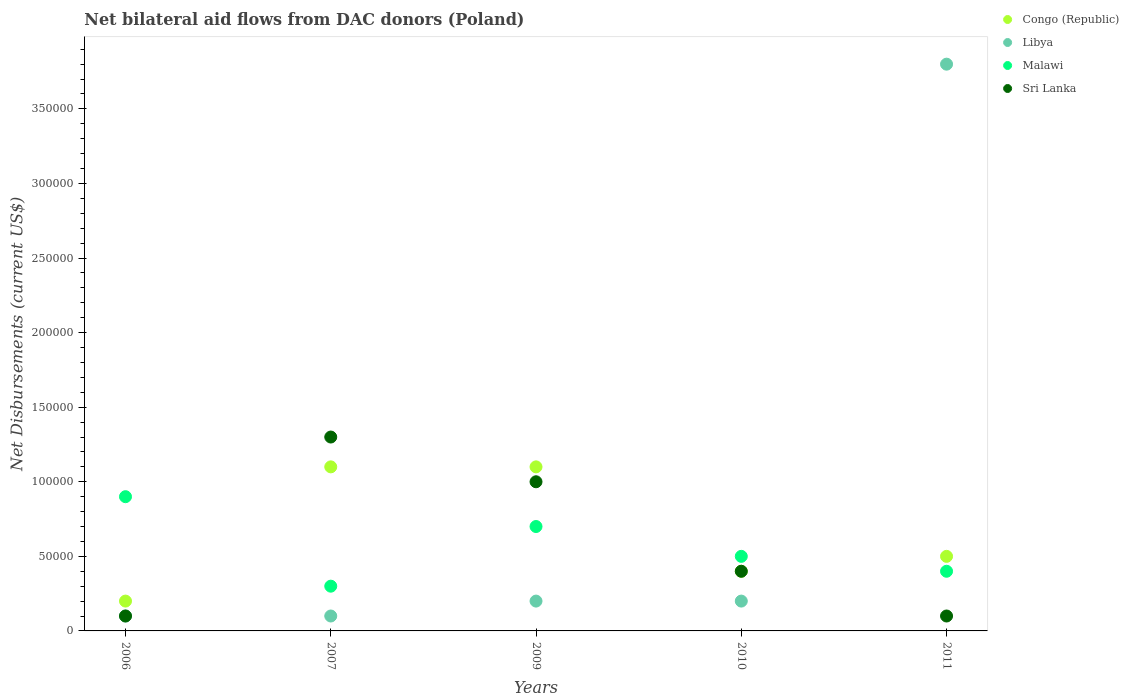How many different coloured dotlines are there?
Provide a short and direct response. 4. Across all years, what is the maximum net bilateral aid flows in Libya?
Give a very brief answer. 3.80e+05. Across all years, what is the minimum net bilateral aid flows in Congo (Republic)?
Keep it short and to the point. 2.00e+04. In which year was the net bilateral aid flows in Sri Lanka maximum?
Provide a short and direct response. 2007. In which year was the net bilateral aid flows in Sri Lanka minimum?
Keep it short and to the point. 2006. What is the difference between the net bilateral aid flows in Congo (Republic) in 2007 and that in 2009?
Offer a terse response. 0. What is the difference between the net bilateral aid flows in Sri Lanka in 2011 and the net bilateral aid flows in Libya in 2009?
Offer a terse response. -10000. What is the average net bilateral aid flows in Libya per year?
Ensure brevity in your answer.  8.80e+04. In the year 2009, what is the difference between the net bilateral aid flows in Libya and net bilateral aid flows in Malawi?
Make the answer very short. -5.00e+04. What is the ratio of the net bilateral aid flows in Sri Lanka in 2009 to that in 2011?
Your response must be concise. 10. What is the difference between the highest and the second highest net bilateral aid flows in Malawi?
Your answer should be very brief. 2.00e+04. What is the difference between the highest and the lowest net bilateral aid flows in Malawi?
Your answer should be very brief. 6.00e+04. In how many years, is the net bilateral aid flows in Libya greater than the average net bilateral aid flows in Libya taken over all years?
Your answer should be very brief. 1. Is the sum of the net bilateral aid flows in Libya in 2006 and 2010 greater than the maximum net bilateral aid flows in Sri Lanka across all years?
Your response must be concise. No. Is it the case that in every year, the sum of the net bilateral aid flows in Libya and net bilateral aid flows in Malawi  is greater than the net bilateral aid flows in Congo (Republic)?
Your response must be concise. No. Is the net bilateral aid flows in Sri Lanka strictly greater than the net bilateral aid flows in Congo (Republic) over the years?
Give a very brief answer. No. Is the net bilateral aid flows in Libya strictly less than the net bilateral aid flows in Congo (Republic) over the years?
Offer a very short reply. No. How many dotlines are there?
Your answer should be very brief. 4. Does the graph contain any zero values?
Keep it short and to the point. No. Does the graph contain grids?
Your response must be concise. No. How are the legend labels stacked?
Make the answer very short. Vertical. What is the title of the graph?
Your answer should be compact. Net bilateral aid flows from DAC donors (Poland). What is the label or title of the Y-axis?
Provide a succinct answer. Net Disbursements (current US$). What is the Net Disbursements (current US$) of Congo (Republic) in 2006?
Ensure brevity in your answer.  2.00e+04. What is the Net Disbursements (current US$) of Sri Lanka in 2006?
Offer a terse response. 10000. What is the Net Disbursements (current US$) of Sri Lanka in 2007?
Keep it short and to the point. 1.30e+05. What is the Net Disbursements (current US$) in Congo (Republic) in 2009?
Your response must be concise. 1.10e+05. What is the Net Disbursements (current US$) in Malawi in 2009?
Provide a short and direct response. 7.00e+04. What is the Net Disbursements (current US$) in Libya in 2010?
Your answer should be compact. 2.00e+04. What is the Net Disbursements (current US$) in Malawi in 2010?
Provide a short and direct response. 5.00e+04. What is the Net Disbursements (current US$) in Congo (Republic) in 2011?
Your response must be concise. 5.00e+04. What is the Net Disbursements (current US$) of Sri Lanka in 2011?
Provide a short and direct response. 10000. Across all years, what is the maximum Net Disbursements (current US$) of Congo (Republic)?
Ensure brevity in your answer.  1.10e+05. Across all years, what is the maximum Net Disbursements (current US$) in Libya?
Provide a succinct answer. 3.80e+05. Across all years, what is the maximum Net Disbursements (current US$) in Malawi?
Provide a succinct answer. 9.00e+04. Across all years, what is the maximum Net Disbursements (current US$) of Sri Lanka?
Keep it short and to the point. 1.30e+05. Across all years, what is the minimum Net Disbursements (current US$) in Congo (Republic)?
Keep it short and to the point. 2.00e+04. What is the total Net Disbursements (current US$) in Libya in the graph?
Give a very brief answer. 4.40e+05. What is the difference between the Net Disbursements (current US$) in Congo (Republic) in 2006 and that in 2007?
Your response must be concise. -9.00e+04. What is the difference between the Net Disbursements (current US$) in Sri Lanka in 2006 and that in 2007?
Your response must be concise. -1.20e+05. What is the difference between the Net Disbursements (current US$) in Congo (Republic) in 2006 and that in 2009?
Your answer should be very brief. -9.00e+04. What is the difference between the Net Disbursements (current US$) of Congo (Republic) in 2006 and that in 2010?
Your response must be concise. -2.00e+04. What is the difference between the Net Disbursements (current US$) in Libya in 2006 and that in 2011?
Make the answer very short. -3.70e+05. What is the difference between the Net Disbursements (current US$) in Sri Lanka in 2006 and that in 2011?
Offer a very short reply. 0. What is the difference between the Net Disbursements (current US$) in Libya in 2007 and that in 2009?
Provide a succinct answer. -10000. What is the difference between the Net Disbursements (current US$) in Congo (Republic) in 2007 and that in 2010?
Provide a succinct answer. 7.00e+04. What is the difference between the Net Disbursements (current US$) in Malawi in 2007 and that in 2010?
Ensure brevity in your answer.  -2.00e+04. What is the difference between the Net Disbursements (current US$) of Libya in 2007 and that in 2011?
Your answer should be very brief. -3.70e+05. What is the difference between the Net Disbursements (current US$) of Sri Lanka in 2007 and that in 2011?
Offer a terse response. 1.20e+05. What is the difference between the Net Disbursements (current US$) of Libya in 2009 and that in 2010?
Your answer should be very brief. 0. What is the difference between the Net Disbursements (current US$) of Sri Lanka in 2009 and that in 2010?
Ensure brevity in your answer.  6.00e+04. What is the difference between the Net Disbursements (current US$) of Congo (Republic) in 2009 and that in 2011?
Make the answer very short. 6.00e+04. What is the difference between the Net Disbursements (current US$) in Libya in 2009 and that in 2011?
Offer a very short reply. -3.60e+05. What is the difference between the Net Disbursements (current US$) in Malawi in 2009 and that in 2011?
Give a very brief answer. 3.00e+04. What is the difference between the Net Disbursements (current US$) of Congo (Republic) in 2010 and that in 2011?
Ensure brevity in your answer.  -10000. What is the difference between the Net Disbursements (current US$) of Libya in 2010 and that in 2011?
Make the answer very short. -3.60e+05. What is the difference between the Net Disbursements (current US$) in Malawi in 2010 and that in 2011?
Give a very brief answer. 10000. What is the difference between the Net Disbursements (current US$) in Sri Lanka in 2010 and that in 2011?
Make the answer very short. 3.00e+04. What is the difference between the Net Disbursements (current US$) in Congo (Republic) in 2006 and the Net Disbursements (current US$) in Malawi in 2007?
Provide a succinct answer. -10000. What is the difference between the Net Disbursements (current US$) of Libya in 2006 and the Net Disbursements (current US$) of Malawi in 2007?
Give a very brief answer. -2.00e+04. What is the difference between the Net Disbursements (current US$) of Libya in 2006 and the Net Disbursements (current US$) of Sri Lanka in 2007?
Your answer should be very brief. -1.20e+05. What is the difference between the Net Disbursements (current US$) of Malawi in 2006 and the Net Disbursements (current US$) of Sri Lanka in 2007?
Give a very brief answer. -4.00e+04. What is the difference between the Net Disbursements (current US$) of Congo (Republic) in 2006 and the Net Disbursements (current US$) of Malawi in 2009?
Provide a short and direct response. -5.00e+04. What is the difference between the Net Disbursements (current US$) in Libya in 2006 and the Net Disbursements (current US$) in Malawi in 2009?
Offer a terse response. -6.00e+04. What is the difference between the Net Disbursements (current US$) in Libya in 2006 and the Net Disbursements (current US$) in Sri Lanka in 2009?
Your answer should be compact. -9.00e+04. What is the difference between the Net Disbursements (current US$) of Congo (Republic) in 2006 and the Net Disbursements (current US$) of Libya in 2010?
Provide a short and direct response. 0. What is the difference between the Net Disbursements (current US$) in Congo (Republic) in 2006 and the Net Disbursements (current US$) in Malawi in 2010?
Provide a succinct answer. -3.00e+04. What is the difference between the Net Disbursements (current US$) in Congo (Republic) in 2006 and the Net Disbursements (current US$) in Sri Lanka in 2010?
Ensure brevity in your answer.  -2.00e+04. What is the difference between the Net Disbursements (current US$) of Libya in 2006 and the Net Disbursements (current US$) of Malawi in 2010?
Provide a short and direct response. -4.00e+04. What is the difference between the Net Disbursements (current US$) in Libya in 2006 and the Net Disbursements (current US$) in Sri Lanka in 2010?
Your answer should be very brief. -3.00e+04. What is the difference between the Net Disbursements (current US$) in Congo (Republic) in 2006 and the Net Disbursements (current US$) in Libya in 2011?
Your answer should be very brief. -3.60e+05. What is the difference between the Net Disbursements (current US$) in Congo (Republic) in 2006 and the Net Disbursements (current US$) in Malawi in 2011?
Give a very brief answer. -2.00e+04. What is the difference between the Net Disbursements (current US$) in Malawi in 2006 and the Net Disbursements (current US$) in Sri Lanka in 2011?
Ensure brevity in your answer.  8.00e+04. What is the difference between the Net Disbursements (current US$) of Congo (Republic) in 2007 and the Net Disbursements (current US$) of Libya in 2009?
Your response must be concise. 9.00e+04. What is the difference between the Net Disbursements (current US$) in Libya in 2007 and the Net Disbursements (current US$) in Malawi in 2009?
Give a very brief answer. -6.00e+04. What is the difference between the Net Disbursements (current US$) in Libya in 2007 and the Net Disbursements (current US$) in Sri Lanka in 2009?
Offer a very short reply. -9.00e+04. What is the difference between the Net Disbursements (current US$) in Congo (Republic) in 2007 and the Net Disbursements (current US$) in Libya in 2010?
Your answer should be compact. 9.00e+04. What is the difference between the Net Disbursements (current US$) of Congo (Republic) in 2007 and the Net Disbursements (current US$) of Malawi in 2010?
Keep it short and to the point. 6.00e+04. What is the difference between the Net Disbursements (current US$) of Libya in 2007 and the Net Disbursements (current US$) of Sri Lanka in 2010?
Your answer should be very brief. -3.00e+04. What is the difference between the Net Disbursements (current US$) in Congo (Republic) in 2007 and the Net Disbursements (current US$) in Malawi in 2011?
Ensure brevity in your answer.  7.00e+04. What is the difference between the Net Disbursements (current US$) of Libya in 2007 and the Net Disbursements (current US$) of Sri Lanka in 2011?
Offer a terse response. 0. What is the difference between the Net Disbursements (current US$) in Congo (Republic) in 2009 and the Net Disbursements (current US$) in Libya in 2010?
Make the answer very short. 9.00e+04. What is the difference between the Net Disbursements (current US$) in Congo (Republic) in 2009 and the Net Disbursements (current US$) in Malawi in 2010?
Provide a short and direct response. 6.00e+04. What is the difference between the Net Disbursements (current US$) in Malawi in 2009 and the Net Disbursements (current US$) in Sri Lanka in 2010?
Offer a very short reply. 3.00e+04. What is the difference between the Net Disbursements (current US$) of Congo (Republic) in 2009 and the Net Disbursements (current US$) of Libya in 2011?
Offer a very short reply. -2.70e+05. What is the difference between the Net Disbursements (current US$) of Congo (Republic) in 2009 and the Net Disbursements (current US$) of Sri Lanka in 2011?
Provide a succinct answer. 1.00e+05. What is the difference between the Net Disbursements (current US$) of Libya in 2009 and the Net Disbursements (current US$) of Malawi in 2011?
Keep it short and to the point. -2.00e+04. What is the difference between the Net Disbursements (current US$) of Libya in 2009 and the Net Disbursements (current US$) of Sri Lanka in 2011?
Give a very brief answer. 10000. What is the difference between the Net Disbursements (current US$) of Malawi in 2009 and the Net Disbursements (current US$) of Sri Lanka in 2011?
Give a very brief answer. 6.00e+04. What is the difference between the Net Disbursements (current US$) in Congo (Republic) in 2010 and the Net Disbursements (current US$) in Libya in 2011?
Provide a succinct answer. -3.40e+05. What is the difference between the Net Disbursements (current US$) of Congo (Republic) in 2010 and the Net Disbursements (current US$) of Malawi in 2011?
Offer a terse response. 0. What is the difference between the Net Disbursements (current US$) of Congo (Republic) in 2010 and the Net Disbursements (current US$) of Sri Lanka in 2011?
Keep it short and to the point. 3.00e+04. What is the difference between the Net Disbursements (current US$) in Malawi in 2010 and the Net Disbursements (current US$) in Sri Lanka in 2011?
Make the answer very short. 4.00e+04. What is the average Net Disbursements (current US$) in Congo (Republic) per year?
Make the answer very short. 6.60e+04. What is the average Net Disbursements (current US$) of Libya per year?
Your response must be concise. 8.80e+04. What is the average Net Disbursements (current US$) in Malawi per year?
Ensure brevity in your answer.  5.60e+04. What is the average Net Disbursements (current US$) of Sri Lanka per year?
Offer a terse response. 5.80e+04. In the year 2006, what is the difference between the Net Disbursements (current US$) of Congo (Republic) and Net Disbursements (current US$) of Libya?
Provide a short and direct response. 10000. In the year 2006, what is the difference between the Net Disbursements (current US$) in Congo (Republic) and Net Disbursements (current US$) in Sri Lanka?
Make the answer very short. 10000. In the year 2006, what is the difference between the Net Disbursements (current US$) in Libya and Net Disbursements (current US$) in Sri Lanka?
Offer a very short reply. 0. In the year 2006, what is the difference between the Net Disbursements (current US$) of Malawi and Net Disbursements (current US$) of Sri Lanka?
Keep it short and to the point. 8.00e+04. In the year 2007, what is the difference between the Net Disbursements (current US$) of Libya and Net Disbursements (current US$) of Malawi?
Your answer should be very brief. -2.00e+04. In the year 2007, what is the difference between the Net Disbursements (current US$) of Libya and Net Disbursements (current US$) of Sri Lanka?
Offer a very short reply. -1.20e+05. In the year 2007, what is the difference between the Net Disbursements (current US$) of Malawi and Net Disbursements (current US$) of Sri Lanka?
Your response must be concise. -1.00e+05. In the year 2009, what is the difference between the Net Disbursements (current US$) of Congo (Republic) and Net Disbursements (current US$) of Malawi?
Offer a terse response. 4.00e+04. In the year 2009, what is the difference between the Net Disbursements (current US$) of Libya and Net Disbursements (current US$) of Malawi?
Your answer should be compact. -5.00e+04. In the year 2010, what is the difference between the Net Disbursements (current US$) of Congo (Republic) and Net Disbursements (current US$) of Malawi?
Make the answer very short. -10000. In the year 2010, what is the difference between the Net Disbursements (current US$) in Libya and Net Disbursements (current US$) in Malawi?
Offer a terse response. -3.00e+04. In the year 2010, what is the difference between the Net Disbursements (current US$) of Malawi and Net Disbursements (current US$) of Sri Lanka?
Make the answer very short. 10000. In the year 2011, what is the difference between the Net Disbursements (current US$) in Congo (Republic) and Net Disbursements (current US$) in Libya?
Your response must be concise. -3.30e+05. In the year 2011, what is the difference between the Net Disbursements (current US$) of Libya and Net Disbursements (current US$) of Malawi?
Your answer should be compact. 3.40e+05. In the year 2011, what is the difference between the Net Disbursements (current US$) in Libya and Net Disbursements (current US$) in Sri Lanka?
Offer a very short reply. 3.70e+05. In the year 2011, what is the difference between the Net Disbursements (current US$) of Malawi and Net Disbursements (current US$) of Sri Lanka?
Make the answer very short. 3.00e+04. What is the ratio of the Net Disbursements (current US$) of Congo (Republic) in 2006 to that in 2007?
Keep it short and to the point. 0.18. What is the ratio of the Net Disbursements (current US$) of Malawi in 2006 to that in 2007?
Make the answer very short. 3. What is the ratio of the Net Disbursements (current US$) of Sri Lanka in 2006 to that in 2007?
Your response must be concise. 0.08. What is the ratio of the Net Disbursements (current US$) of Congo (Republic) in 2006 to that in 2009?
Make the answer very short. 0.18. What is the ratio of the Net Disbursements (current US$) in Sri Lanka in 2006 to that in 2009?
Ensure brevity in your answer.  0.1. What is the ratio of the Net Disbursements (current US$) in Libya in 2006 to that in 2010?
Provide a succinct answer. 0.5. What is the ratio of the Net Disbursements (current US$) in Malawi in 2006 to that in 2010?
Your answer should be very brief. 1.8. What is the ratio of the Net Disbursements (current US$) in Libya in 2006 to that in 2011?
Your answer should be very brief. 0.03. What is the ratio of the Net Disbursements (current US$) of Malawi in 2006 to that in 2011?
Make the answer very short. 2.25. What is the ratio of the Net Disbursements (current US$) in Sri Lanka in 2006 to that in 2011?
Give a very brief answer. 1. What is the ratio of the Net Disbursements (current US$) of Libya in 2007 to that in 2009?
Your answer should be very brief. 0.5. What is the ratio of the Net Disbursements (current US$) of Malawi in 2007 to that in 2009?
Ensure brevity in your answer.  0.43. What is the ratio of the Net Disbursements (current US$) of Congo (Republic) in 2007 to that in 2010?
Provide a succinct answer. 2.75. What is the ratio of the Net Disbursements (current US$) of Libya in 2007 to that in 2010?
Keep it short and to the point. 0.5. What is the ratio of the Net Disbursements (current US$) in Malawi in 2007 to that in 2010?
Make the answer very short. 0.6. What is the ratio of the Net Disbursements (current US$) in Sri Lanka in 2007 to that in 2010?
Offer a very short reply. 3.25. What is the ratio of the Net Disbursements (current US$) in Congo (Republic) in 2007 to that in 2011?
Your response must be concise. 2.2. What is the ratio of the Net Disbursements (current US$) in Libya in 2007 to that in 2011?
Give a very brief answer. 0.03. What is the ratio of the Net Disbursements (current US$) in Sri Lanka in 2007 to that in 2011?
Give a very brief answer. 13. What is the ratio of the Net Disbursements (current US$) in Congo (Republic) in 2009 to that in 2010?
Your answer should be very brief. 2.75. What is the ratio of the Net Disbursements (current US$) in Congo (Republic) in 2009 to that in 2011?
Your answer should be compact. 2.2. What is the ratio of the Net Disbursements (current US$) in Libya in 2009 to that in 2011?
Your response must be concise. 0.05. What is the ratio of the Net Disbursements (current US$) of Libya in 2010 to that in 2011?
Give a very brief answer. 0.05. What is the difference between the highest and the second highest Net Disbursements (current US$) of Sri Lanka?
Provide a short and direct response. 3.00e+04. What is the difference between the highest and the lowest Net Disbursements (current US$) of Congo (Republic)?
Your response must be concise. 9.00e+04. What is the difference between the highest and the lowest Net Disbursements (current US$) in Sri Lanka?
Provide a short and direct response. 1.20e+05. 